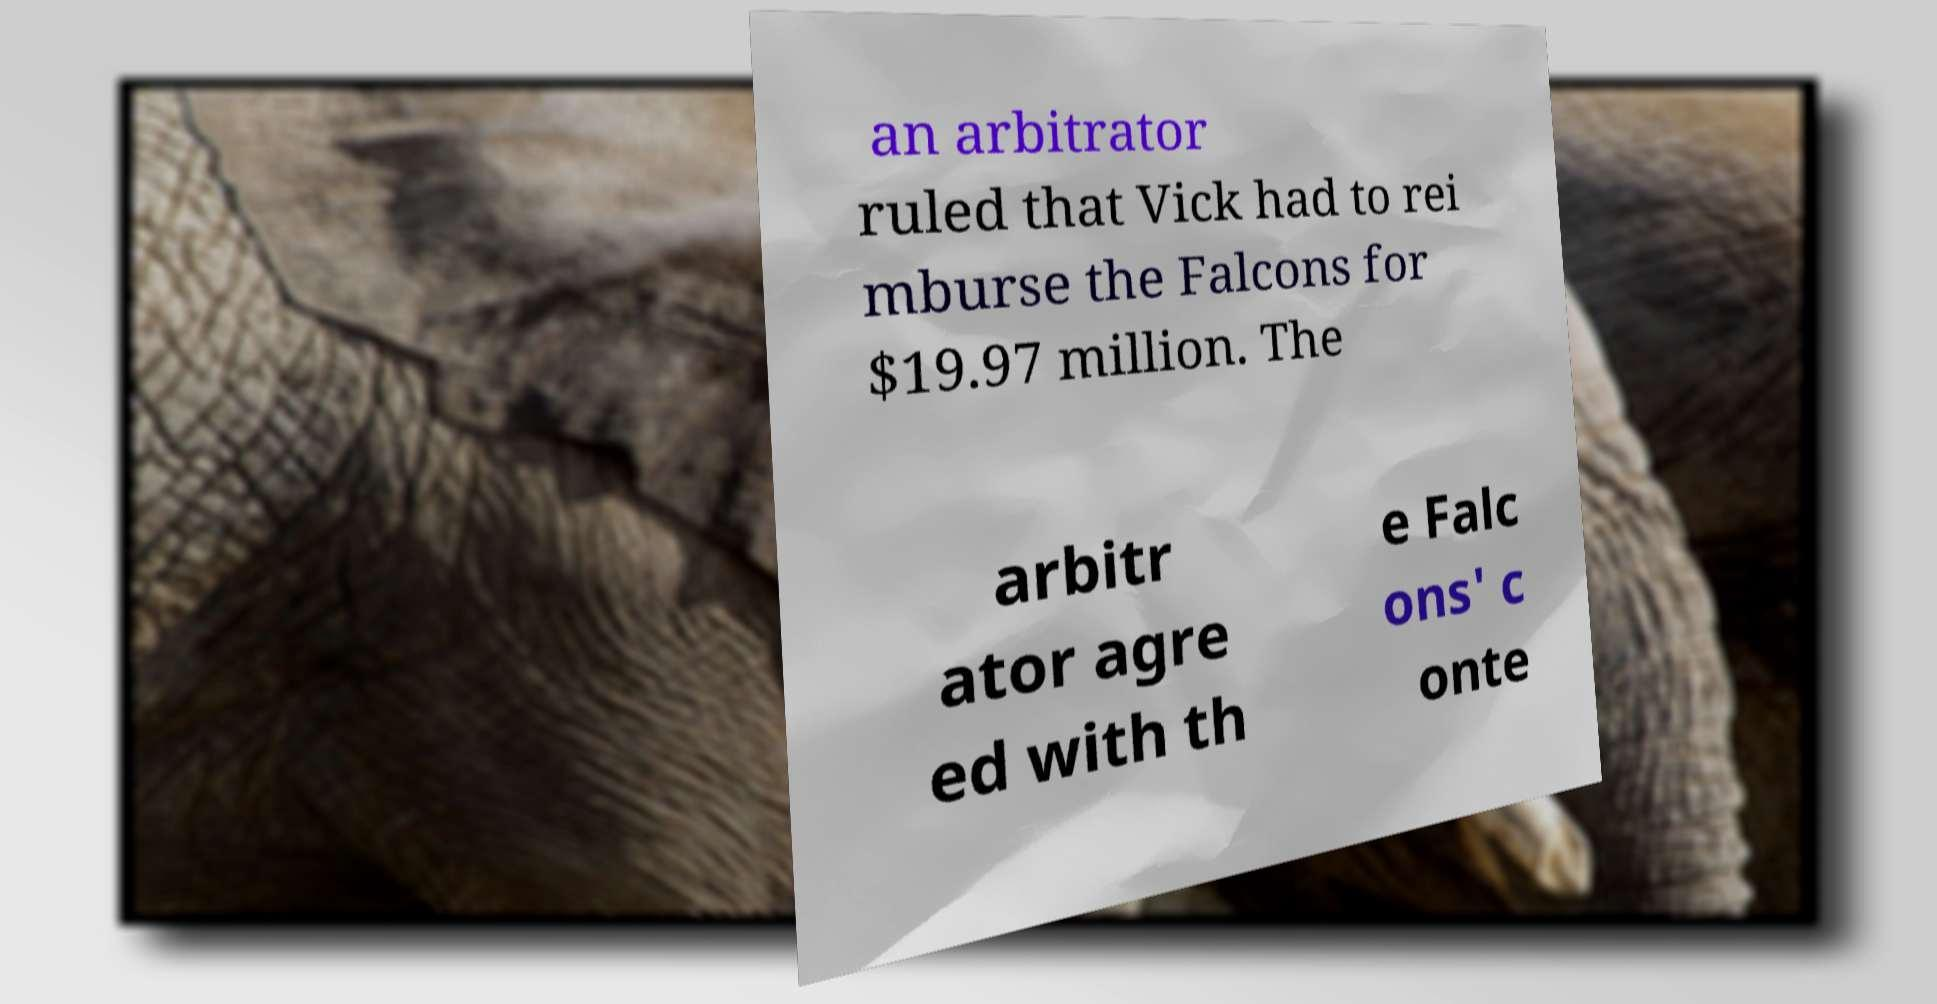Could you extract and type out the text from this image? an arbitrator ruled that Vick had to rei mburse the Falcons for $19.97 million. The arbitr ator agre ed with th e Falc ons' c onte 